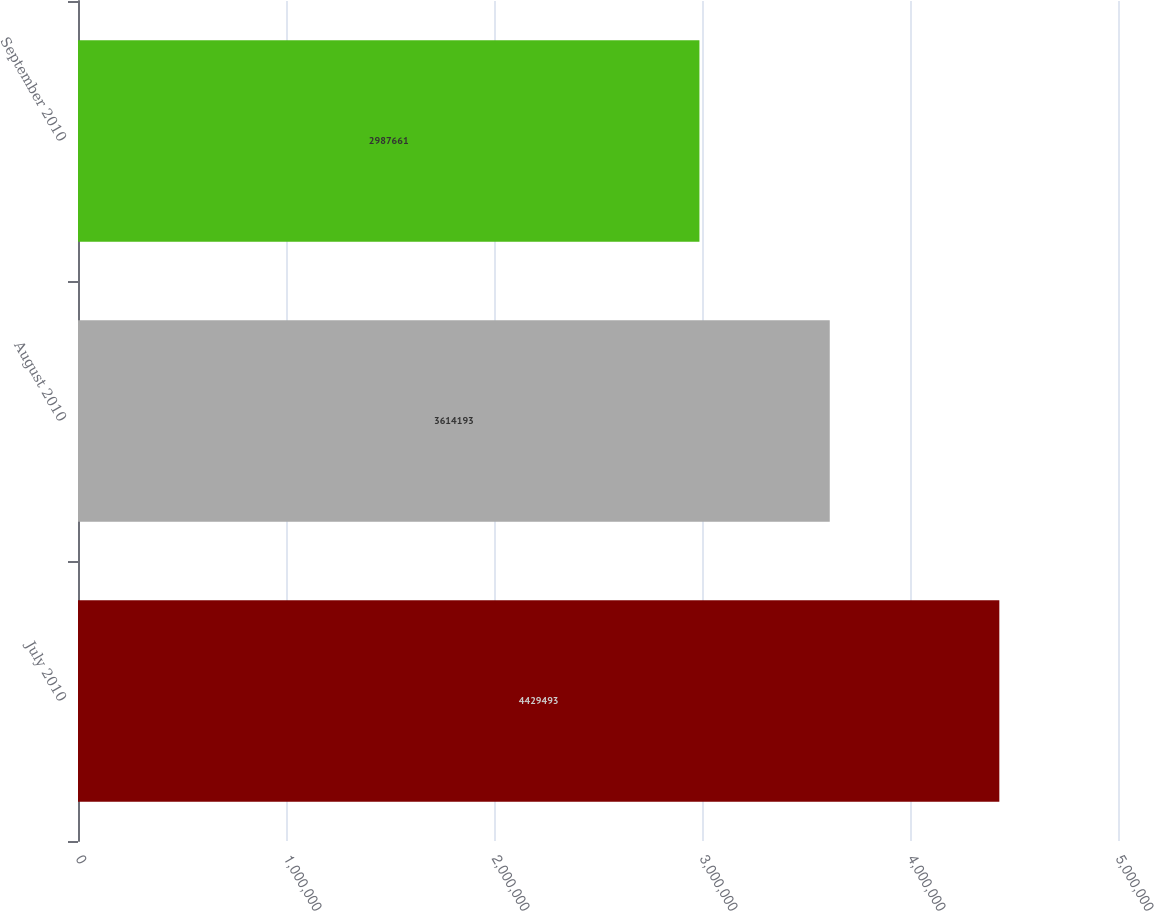<chart> <loc_0><loc_0><loc_500><loc_500><bar_chart><fcel>July 2010<fcel>August 2010<fcel>September 2010<nl><fcel>4.42949e+06<fcel>3.61419e+06<fcel>2.98766e+06<nl></chart> 